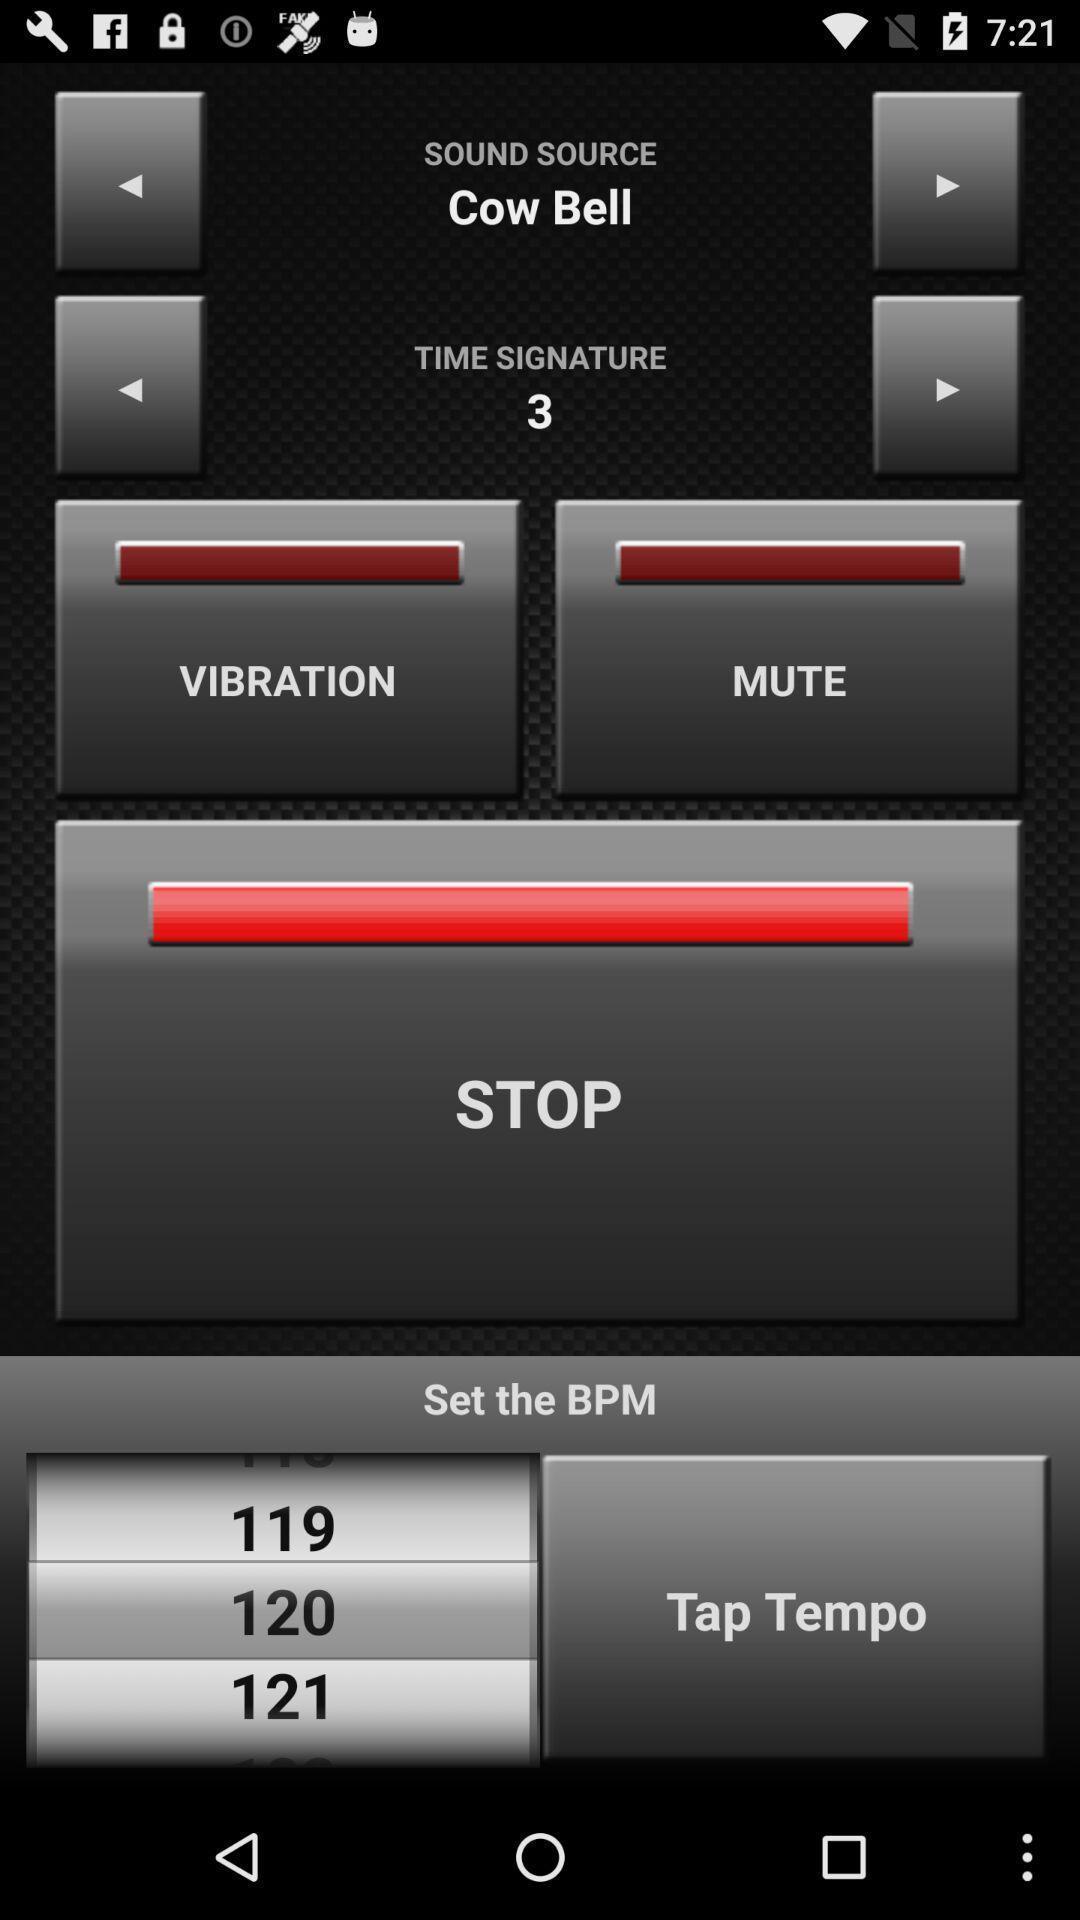Summarize the main components in this picture. Page with some options of a music app. 